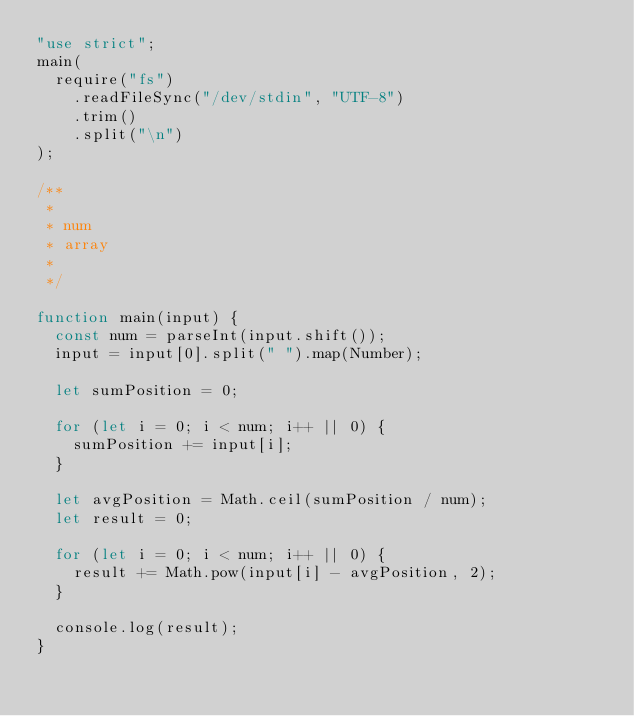<code> <loc_0><loc_0><loc_500><loc_500><_JavaScript_>"use strict";
main(
  require("fs")
    .readFileSync("/dev/stdin", "UTF-8")
    .trim()
    .split("\n")
);

/**
 *
 * num
 * array
 *
 */

function main(input) {
  const num = parseInt(input.shift());
  input = input[0].split(" ").map(Number);

  let sumPosition = 0;

  for (let i = 0; i < num; i++ || 0) {
    sumPosition += input[i];
  }

  let avgPosition = Math.ceil(sumPosition / num);
  let result = 0;

  for (let i = 0; i < num; i++ || 0) {
    result += Math.pow(input[i] - avgPosition, 2);
  }

  console.log(result);
}
</code> 